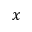Convert formula to latex. <formula><loc_0><loc_0><loc_500><loc_500>x</formula> 